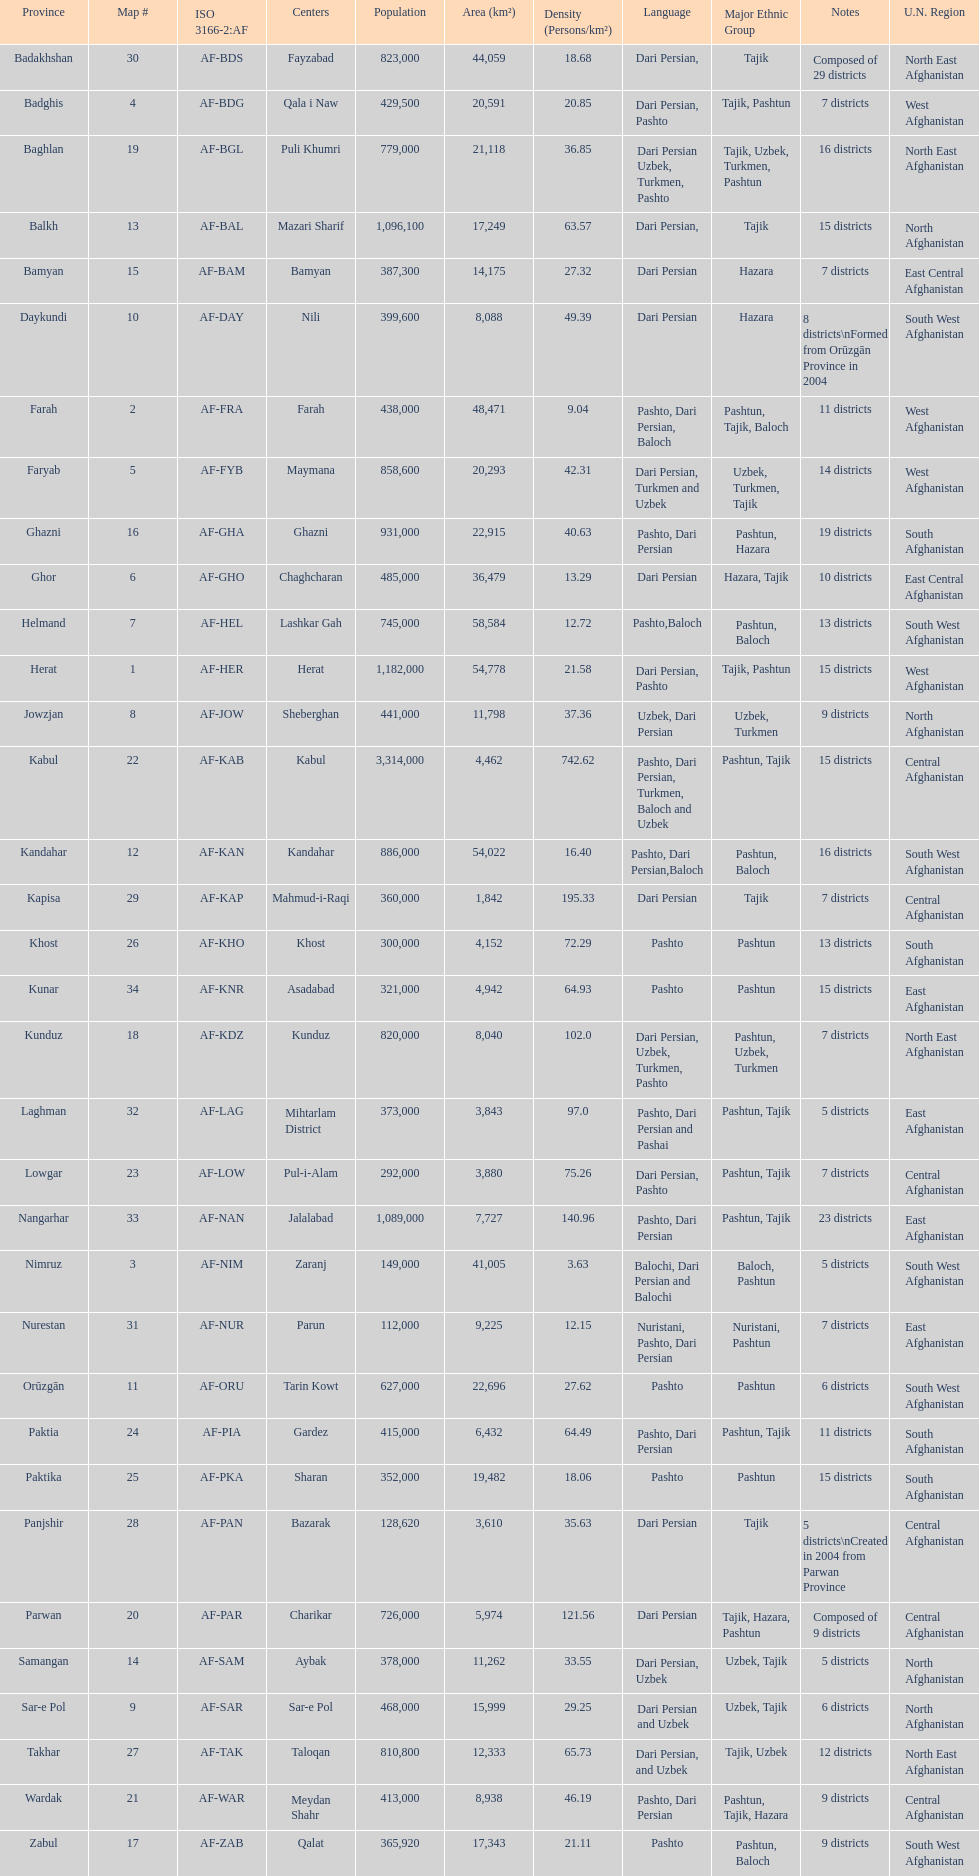What province in afghanistanhas the greatest population? Kabul. 